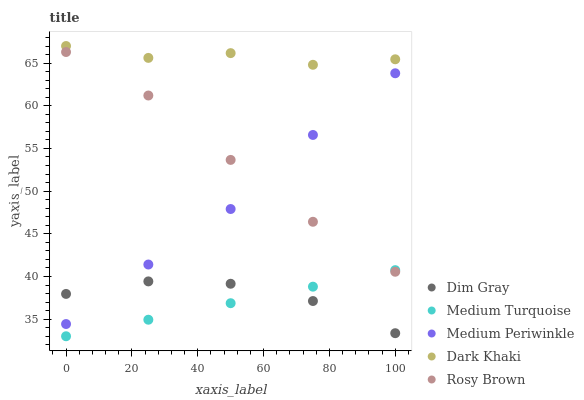Does Medium Turquoise have the minimum area under the curve?
Answer yes or no. Yes. Does Dark Khaki have the maximum area under the curve?
Answer yes or no. Yes. Does Rosy Brown have the minimum area under the curve?
Answer yes or no. No. Does Rosy Brown have the maximum area under the curve?
Answer yes or no. No. Is Medium Turquoise the smoothest?
Answer yes or no. Yes. Is Dark Khaki the roughest?
Answer yes or no. Yes. Is Rosy Brown the smoothest?
Answer yes or no. No. Is Rosy Brown the roughest?
Answer yes or no. No. Does Medium Turquoise have the lowest value?
Answer yes or no. Yes. Does Rosy Brown have the lowest value?
Answer yes or no. No. Does Dark Khaki have the highest value?
Answer yes or no. Yes. Does Rosy Brown have the highest value?
Answer yes or no. No. Is Medium Periwinkle less than Dark Khaki?
Answer yes or no. Yes. Is Dark Khaki greater than Rosy Brown?
Answer yes or no. Yes. Does Dim Gray intersect Medium Turquoise?
Answer yes or no. Yes. Is Dim Gray less than Medium Turquoise?
Answer yes or no. No. Is Dim Gray greater than Medium Turquoise?
Answer yes or no. No. Does Medium Periwinkle intersect Dark Khaki?
Answer yes or no. No. 